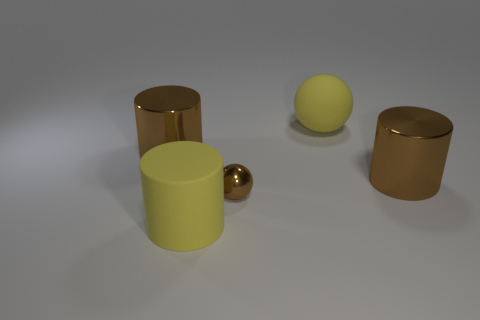Subtract all red balls. Subtract all gray cubes. How many balls are left? 2 Add 1 big green balls. How many objects exist? 6 Subtract all balls. How many objects are left? 3 Add 2 big brown cylinders. How many big brown cylinders exist? 4 Subtract 0 green cubes. How many objects are left? 5 Subtract all brown cylinders. Subtract all big yellow rubber things. How many objects are left? 1 Add 3 big yellow spheres. How many big yellow spheres are left? 4 